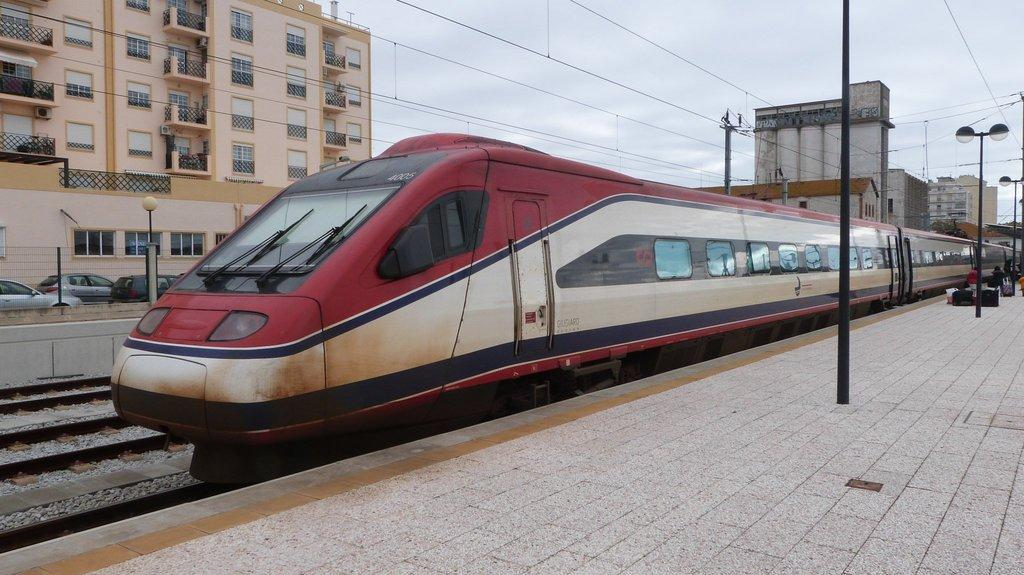What type of vehicle is in the image? There is a metro train in the image. Where is the metro train located? The metro train is at a metro station in the image. What can be seen in the background of the image? Buildings are visible behind the train. What type of transportation is not present in the image? There are no cars visible in the image, only parked cars. What type of wax can be seen melting on the fish in the image? There is no fish or wax present in the image; it features a metro train at a metro station with buildings in the background. 